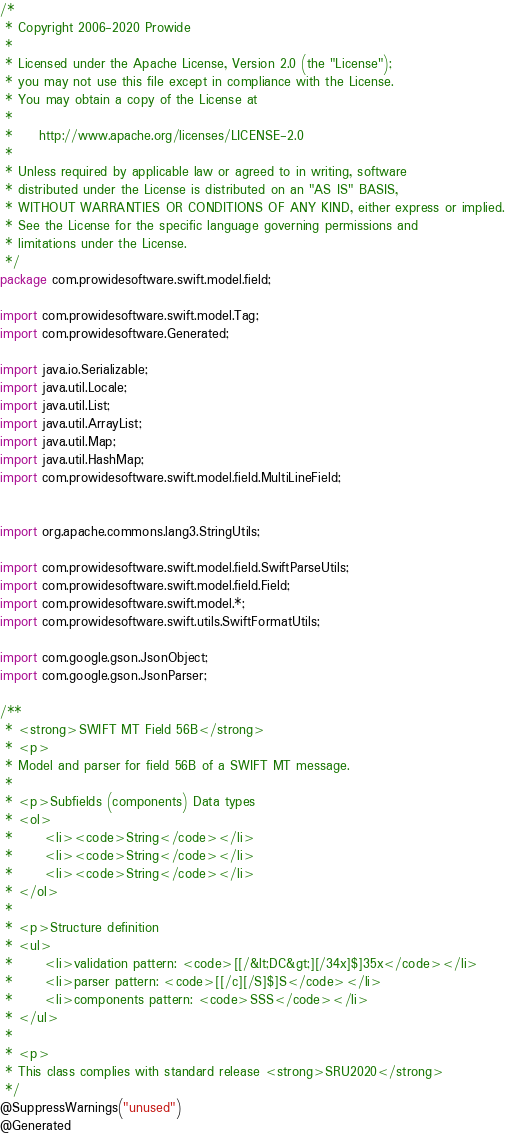<code> <loc_0><loc_0><loc_500><loc_500><_Java_>/*
 * Copyright 2006-2020 Prowide
 *
 * Licensed under the Apache License, Version 2.0 (the "License");
 * you may not use this file except in compliance with the License.
 * You may obtain a copy of the License at
 *
 *     http://www.apache.org/licenses/LICENSE-2.0
 *
 * Unless required by applicable law or agreed to in writing, software
 * distributed under the License is distributed on an "AS IS" BASIS,
 * WITHOUT WARRANTIES OR CONDITIONS OF ANY KIND, either express or implied.
 * See the License for the specific language governing permissions and
 * limitations under the License.
 */
package com.prowidesoftware.swift.model.field;

import com.prowidesoftware.swift.model.Tag;
import com.prowidesoftware.Generated;

import java.io.Serializable;
import java.util.Locale;
import java.util.List;
import java.util.ArrayList;
import java.util.Map;
import java.util.HashMap;
import com.prowidesoftware.swift.model.field.MultiLineField;


import org.apache.commons.lang3.StringUtils;

import com.prowidesoftware.swift.model.field.SwiftParseUtils;
import com.prowidesoftware.swift.model.field.Field;
import com.prowidesoftware.swift.model.*;
import com.prowidesoftware.swift.utils.SwiftFormatUtils;

import com.google.gson.JsonObject;
import com.google.gson.JsonParser;

/**
 * <strong>SWIFT MT Field 56B</strong>
 * <p>
 * Model and parser for field 56B of a SWIFT MT message.
 *
 * <p>Subfields (components) Data types
 * <ol>
 * 		<li><code>String</code></li>
 * 		<li><code>String</code></li>
 * 		<li><code>String</code></li>
 * </ol>
 *
 * <p>Structure definition
 * <ul>
 * 		<li>validation pattern: <code>[[/&lt;DC&gt;][/34x]$]35x</code></li>
 * 		<li>parser pattern: <code>[[/c][/S]$]S</code></li>
 * 		<li>components pattern: <code>SSS</code></li>
 * </ul>
 *
 * <p>
 * This class complies with standard release <strong>SRU2020</strong>
 */
@SuppressWarnings("unused")
@Generated</code> 